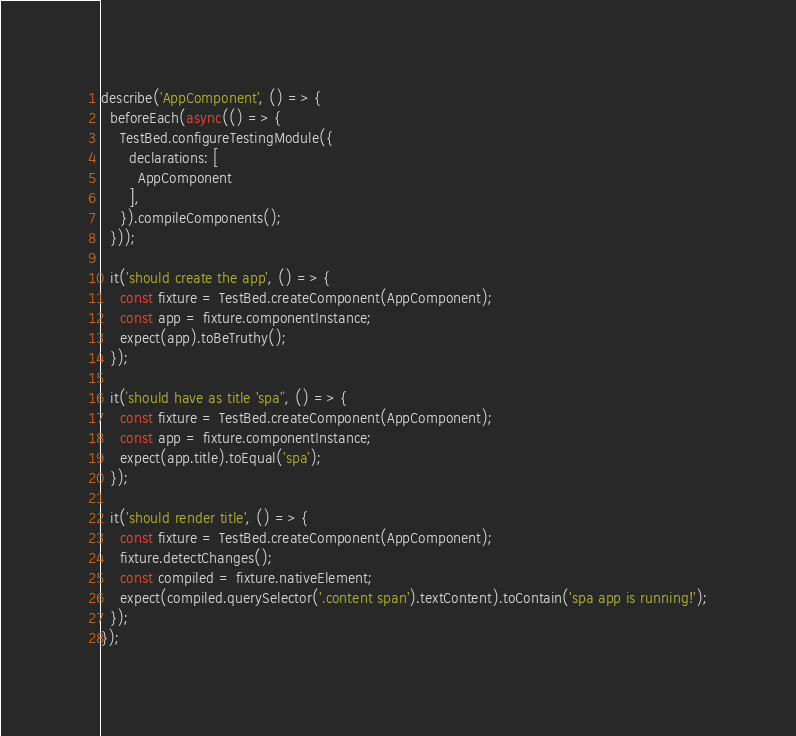Convert code to text. <code><loc_0><loc_0><loc_500><loc_500><_TypeScript_>describe('AppComponent', () => {
  beforeEach(async(() => {
    TestBed.configureTestingModule({
      declarations: [
        AppComponent
      ],
    }).compileComponents();
  }));

  it('should create the app', () => {
    const fixture = TestBed.createComponent(AppComponent);
    const app = fixture.componentInstance;
    expect(app).toBeTruthy();
  });

  it(`should have as title 'spa'`, () => {
    const fixture = TestBed.createComponent(AppComponent);
    const app = fixture.componentInstance;
    expect(app.title).toEqual('spa');
  });

  it('should render title', () => {
    const fixture = TestBed.createComponent(AppComponent);
    fixture.detectChanges();
    const compiled = fixture.nativeElement;
    expect(compiled.querySelector('.content span').textContent).toContain('spa app is running!');
  });
});
</code> 